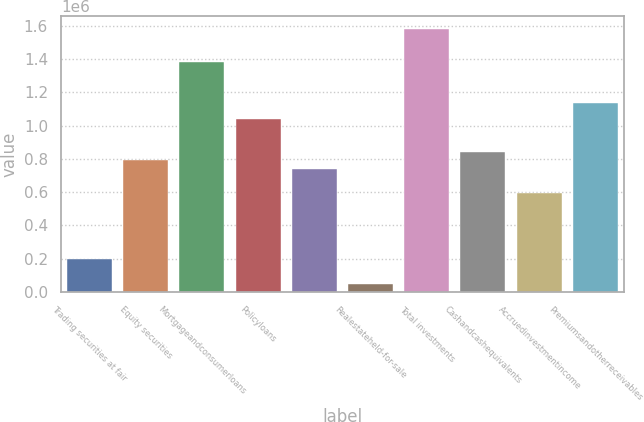Convert chart. <chart><loc_0><loc_0><loc_500><loc_500><bar_chart><fcel>Trading securities at fair<fcel>Equity securities<fcel>Mortgageandconsumerloans<fcel>Policyloans<fcel>Unnamed: 4<fcel>Realestateheld-for-sale<fcel>Total investments<fcel>Cashandcashequivalents<fcel>Accruedinvestmentincome<fcel>Premiumsandotherreceivables<nl><fcel>197567<fcel>790267<fcel>1.38297e+06<fcel>1.03722e+06<fcel>740875<fcel>49392.6<fcel>1.58053e+06<fcel>839658<fcel>592700<fcel>1.13601e+06<nl></chart> 